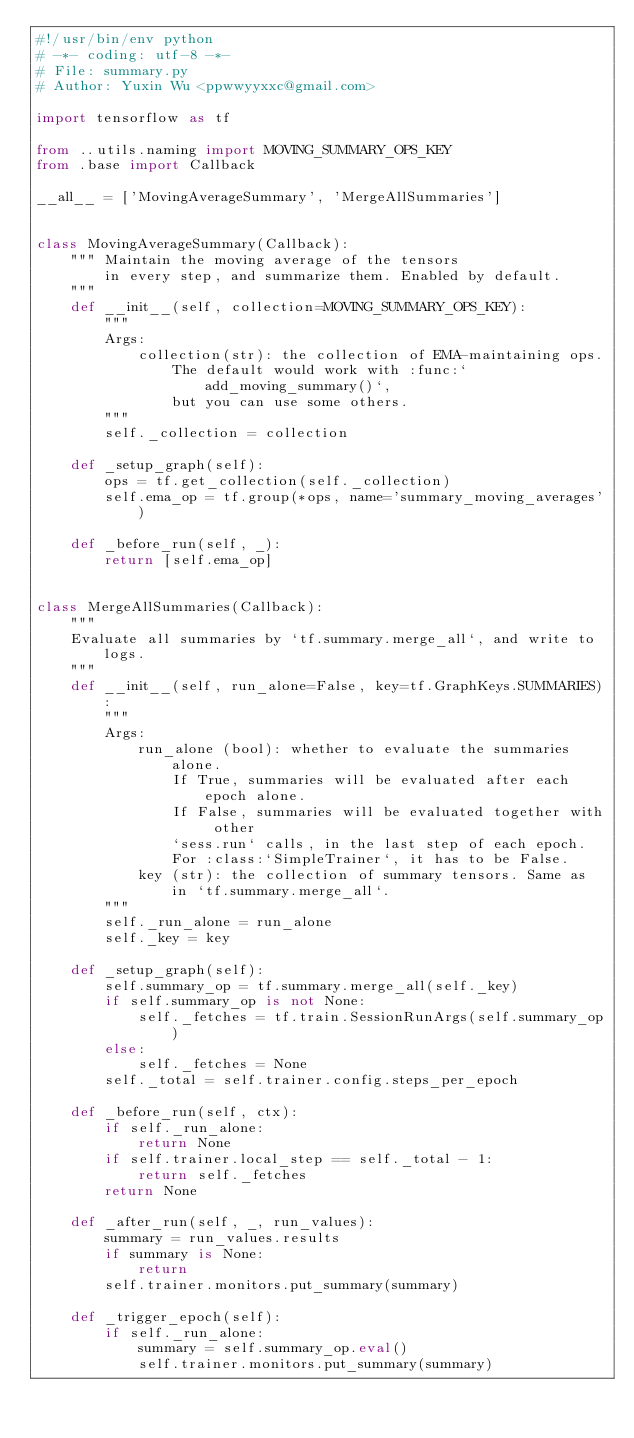<code> <loc_0><loc_0><loc_500><loc_500><_Python_>#!/usr/bin/env python
# -*- coding: utf-8 -*-
# File: summary.py
# Author: Yuxin Wu <ppwwyyxxc@gmail.com>

import tensorflow as tf

from ..utils.naming import MOVING_SUMMARY_OPS_KEY
from .base import Callback

__all__ = ['MovingAverageSummary', 'MergeAllSummaries']


class MovingAverageSummary(Callback):
    """ Maintain the moving average of the tensors
        in every step, and summarize them. Enabled by default.
    """
    def __init__(self, collection=MOVING_SUMMARY_OPS_KEY):
        """
        Args:
            collection(str): the collection of EMA-maintaining ops.
                The default would work with :func:`add_moving_summary()`,
                but you can use some others.
        """
        self._collection = collection

    def _setup_graph(self):
        ops = tf.get_collection(self._collection)
        self.ema_op = tf.group(*ops, name='summary_moving_averages')

    def _before_run(self, _):
        return [self.ema_op]


class MergeAllSummaries(Callback):
    """
    Evaluate all summaries by `tf.summary.merge_all`, and write to logs.
    """
    def __init__(self, run_alone=False, key=tf.GraphKeys.SUMMARIES):
        """
        Args:
            run_alone (bool): whether to evaluate the summaries alone.
                If True, summaries will be evaluated after each epoch alone.
                If False, summaries will be evaluated together with other
                `sess.run` calls, in the last step of each epoch.
                For :class:`SimpleTrainer`, it has to be False.
            key (str): the collection of summary tensors. Same as in `tf.summary.merge_all`.
        """
        self._run_alone = run_alone
        self._key = key

    def _setup_graph(self):
        self.summary_op = tf.summary.merge_all(self._key)
        if self.summary_op is not None:
            self._fetches = tf.train.SessionRunArgs(self.summary_op)
        else:
            self._fetches = None
        self._total = self.trainer.config.steps_per_epoch

    def _before_run(self, ctx):
        if self._run_alone:
            return None
        if self.trainer.local_step == self._total - 1:
            return self._fetches
        return None

    def _after_run(self, _, run_values):
        summary = run_values.results
        if summary is None:
            return
        self.trainer.monitors.put_summary(summary)

    def _trigger_epoch(self):
        if self._run_alone:
            summary = self.summary_op.eval()
            self.trainer.monitors.put_summary(summary)
</code> 